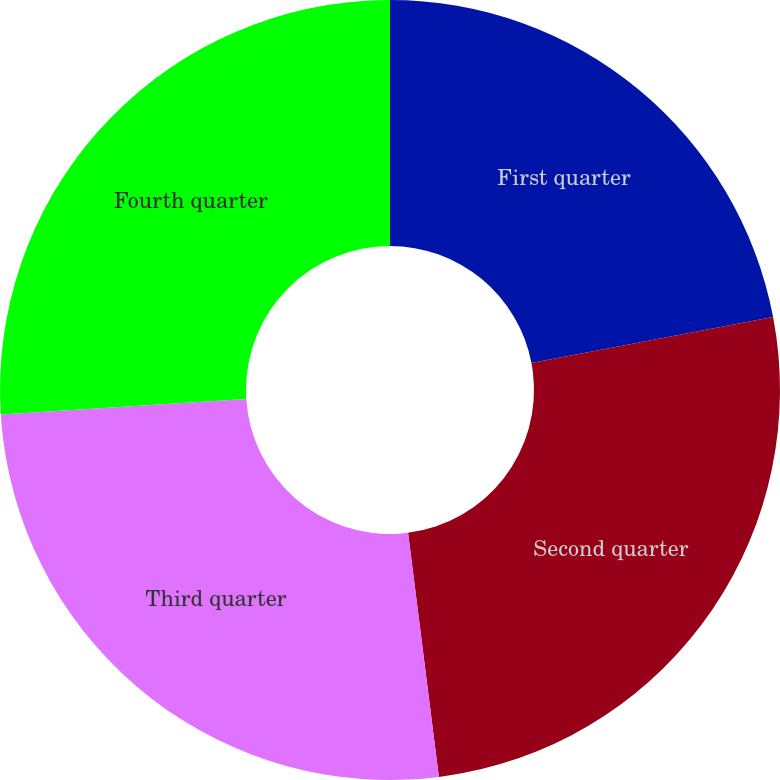Convert chart to OTSL. <chart><loc_0><loc_0><loc_500><loc_500><pie_chart><fcel>First quarter<fcel>Second quarter<fcel>Third quarter<fcel>Fourth quarter<nl><fcel>22.0%<fcel>26.0%<fcel>26.0%<fcel>26.0%<nl></chart> 